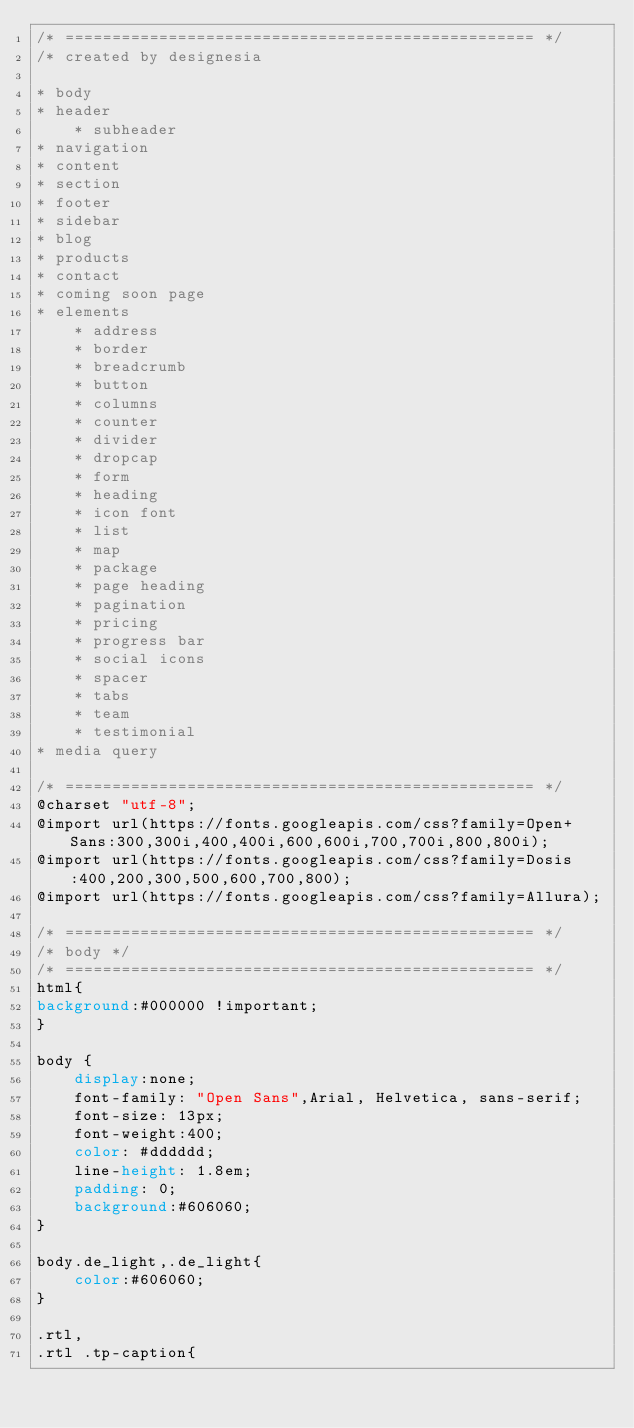<code> <loc_0><loc_0><loc_500><loc_500><_CSS_>/* ================================================== */
/* created by designesia

* body
* header
	* subheader
* navigation
* content
* section
* footer
* sidebar
* blog
* products
* contact
* coming soon page
* elements
	* address
	* border
	* breadcrumb
	* button
	* columns
	* counter
	* divider
	* dropcap
	* form
	* heading
	* icon font
	* list
	* map
	* package
	* page heading
	* pagination
	* pricing
	* progress bar
	* social icons
	* spacer
	* tabs
	* team
	* testimonial
* media query

/* ================================================== */
@charset "utf-8";
@import url(https://fonts.googleapis.com/css?family=Open+Sans:300,300i,400,400i,600,600i,700,700i,800,800i);
@import url(https://fonts.googleapis.com/css?family=Dosis:400,200,300,500,600,700,800);
@import url(https://fonts.googleapis.com/css?family=Allura);

/* ================================================== */
/* body */
/* ================================================== */
html{
background:#000000 !important;
}

body {
	display:none;
	font-family: "Open Sans",Arial, Helvetica, sans-serif;
	font-size: 13px;
	font-weight:400;
	color: #dddddd;
	line-height: 1.8em;
	padding: 0;
	background:#606060;
}

body.de_light,.de_light{
	color:#606060;
}

.rtl,
.rtl .tp-caption{</code> 